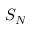<formula> <loc_0><loc_0><loc_500><loc_500>S _ { N }</formula> 